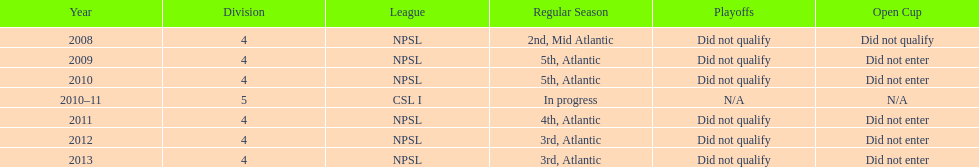How many 3rd place finishes has npsl had? 2. 